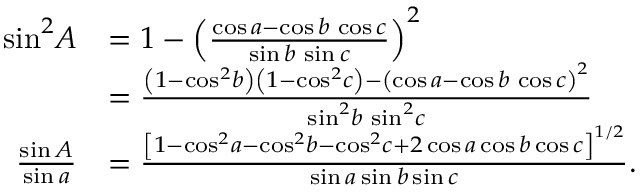<formula> <loc_0><loc_0><loc_500><loc_500>{ \begin{array} { r l } { \sin ^ { 2 } \, A } & { = 1 - \left ( { \frac { \cos a - \cos b \, \cos c } { \sin b \, \sin c } } \right ) ^ { 2 } } \\ & { = { \frac { \left ( 1 - \cos ^ { 2 } \, b \right ) \left ( 1 - \cos ^ { 2 } \, c \right ) - \left ( \cos a - \cos b \, \cos c \right ) ^ { 2 } } { \sin ^ { 2 } \, b \, \sin ^ { 2 } \, c } } } \\ { { \frac { \sin A } { \sin a } } } & { = { \frac { \left [ 1 - \cos ^ { 2 } \, a - \cos ^ { 2 } \, b - \cos ^ { 2 } \, c + 2 \cos a \cos b \cos c \right ] ^ { 1 / 2 } } { \sin a \sin b \sin c } } . } \end{array} }</formula> 